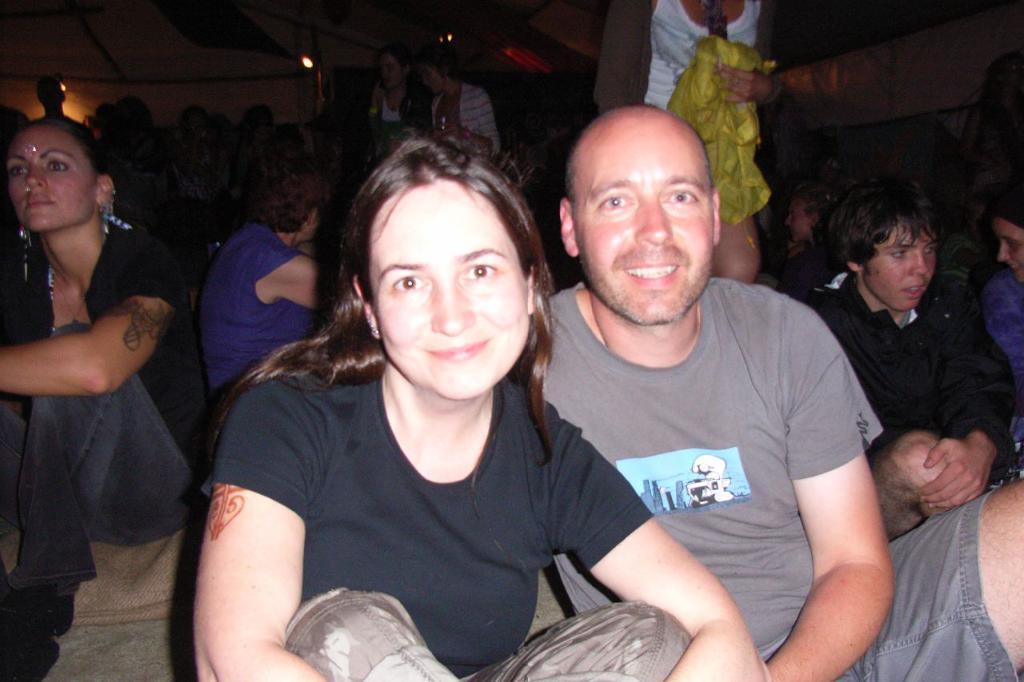How would you summarize this image in a sentence or two? This picture is clicked inside. In the foreground we can see the group of persons sitting on the ground and we can see the group of persons seems to be standing. At the top there is a roof and we can see the lights and some other objects. 